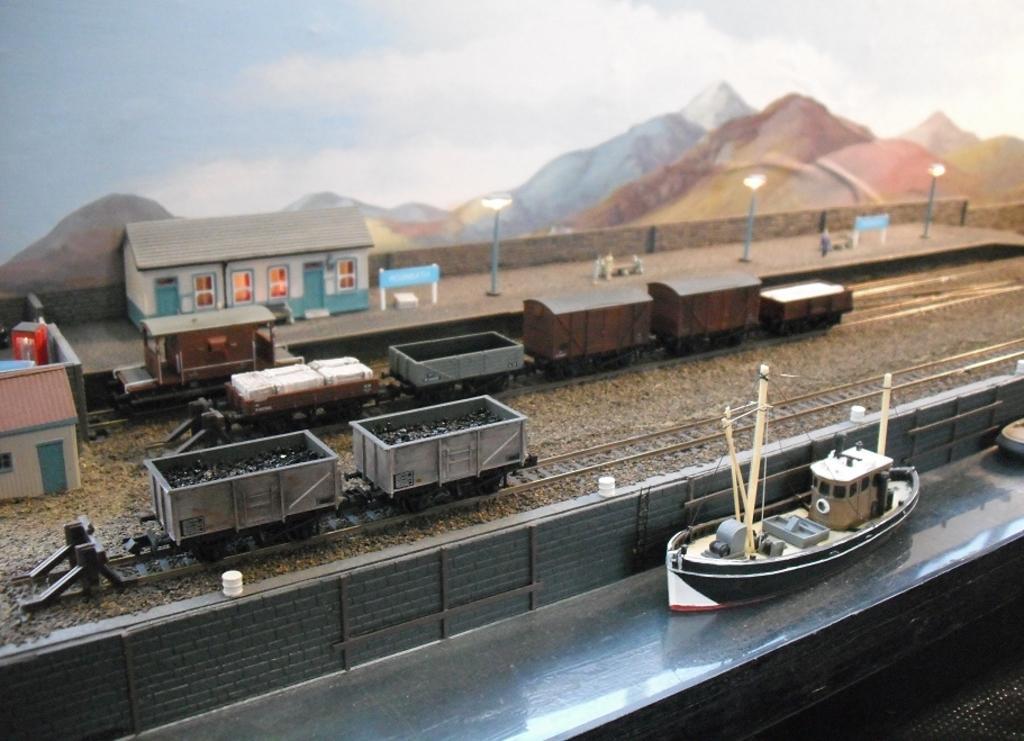Could you give a brief overview of what you see in this image? In this image, we can see a few toys like a ship, trains, houses, railway tracks, hills, poles. We can see the fence and the sky. We can see the ground with some objects. 